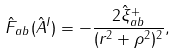Convert formula to latex. <formula><loc_0><loc_0><loc_500><loc_500>\hat { F } _ { a b } ( \hat { A } ^ { I } ) = - \frac { 2 \hat { \xi } _ { a b } ^ { + } } { ( r ^ { 2 } + \rho ^ { 2 } ) ^ { 2 } } ,</formula> 